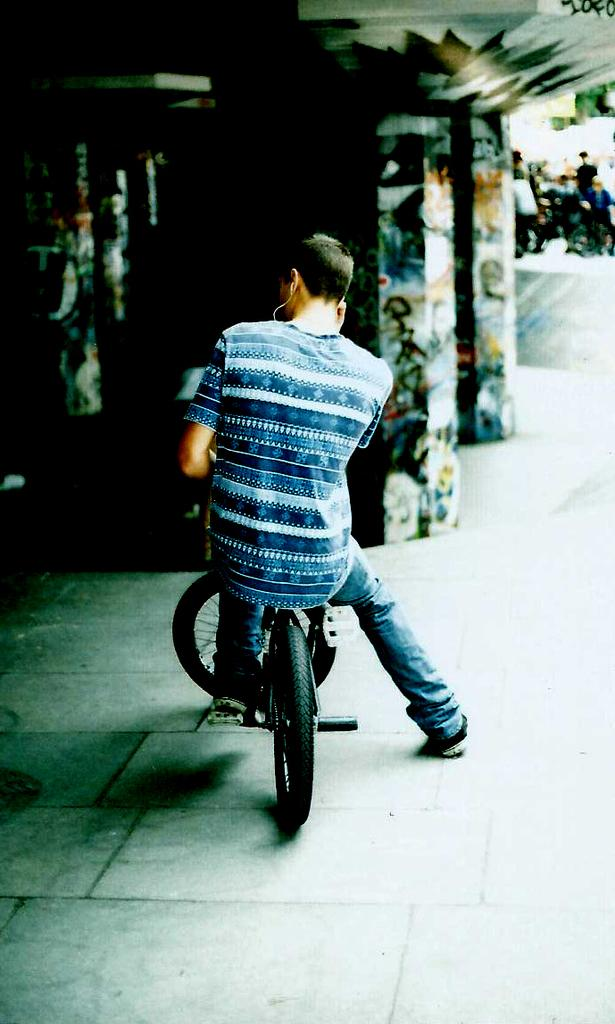Who is the main subject in the image? There is a man in the image. What is the man doing in the image? The man is sitting on a bicycle. What can be seen in the background of the image? There are pillars, a wall, and people standing in the background of the image. What type of steel is used to make the clover visible in the image? There is no steel or clover present in the image. How much sugar is visible in the image? There is no sugar visible in the image. 